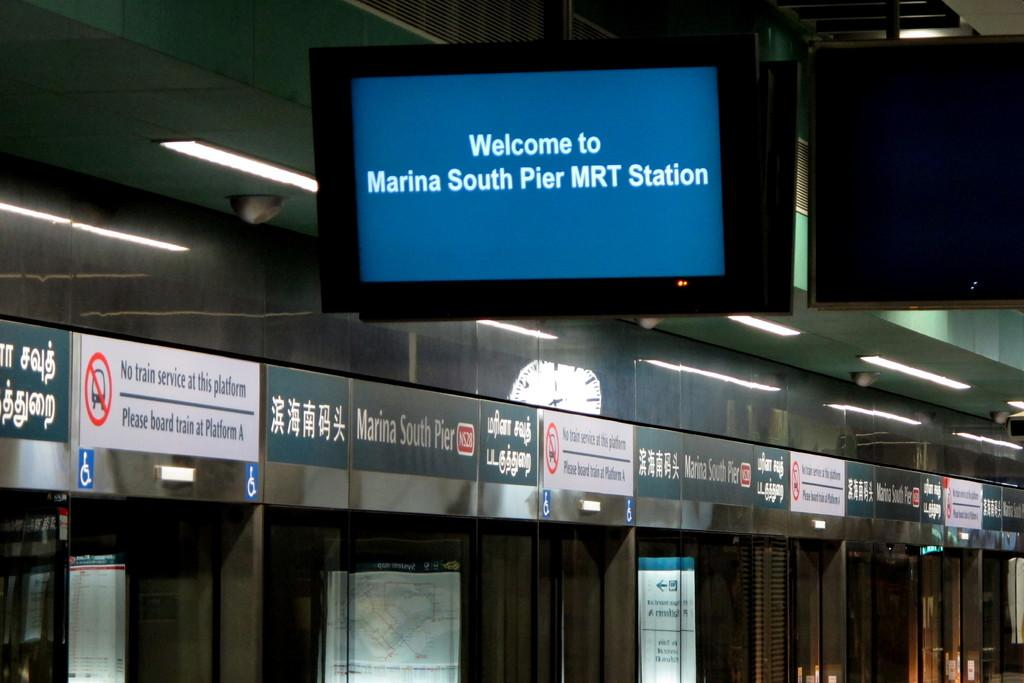<image>
Render a clear and concise summary of the photo. A Tv screen welcomes those to the marina South Pier MRT station. 